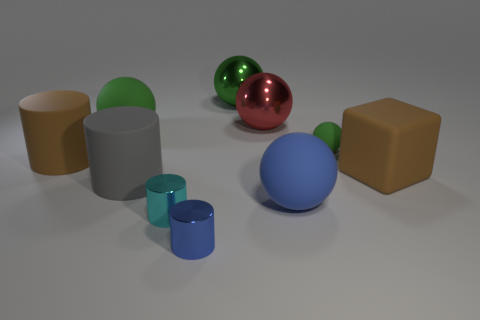Subtract all cyan cylinders. How many green balls are left? 3 Subtract 1 spheres. How many spheres are left? 4 Subtract all small green rubber spheres. How many spheres are left? 4 Subtract all blue balls. How many balls are left? 4 Subtract all purple balls. Subtract all green cylinders. How many balls are left? 5 Subtract all cubes. How many objects are left? 9 Add 6 purple cylinders. How many purple cylinders exist? 6 Subtract 0 purple blocks. How many objects are left? 10 Subtract all cyan objects. Subtract all brown cubes. How many objects are left? 8 Add 5 big matte cylinders. How many big matte cylinders are left? 7 